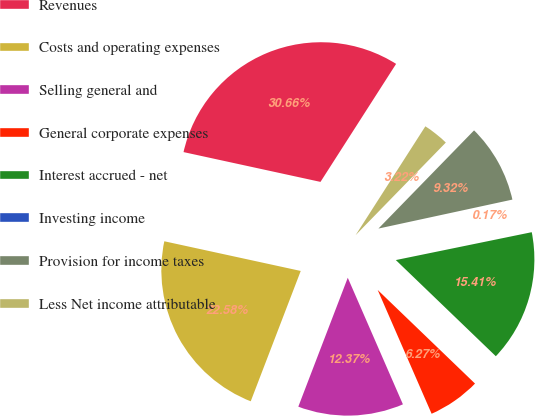Convert chart to OTSL. <chart><loc_0><loc_0><loc_500><loc_500><pie_chart><fcel>Revenues<fcel>Costs and operating expenses<fcel>Selling general and<fcel>General corporate expenses<fcel>Interest accrued - net<fcel>Investing income<fcel>Provision for income taxes<fcel>Less Net income attributable<nl><fcel>30.66%<fcel>22.58%<fcel>12.37%<fcel>6.27%<fcel>15.41%<fcel>0.17%<fcel>9.32%<fcel>3.22%<nl></chart> 